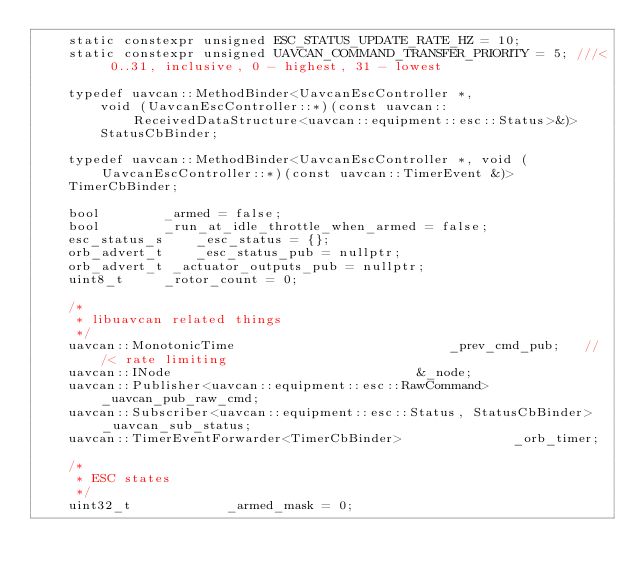Convert code to text. <code><loc_0><loc_0><loc_500><loc_500><_C++_>	static constexpr unsigned ESC_STATUS_UPDATE_RATE_HZ = 10;
	static constexpr unsigned UAVCAN_COMMAND_TRANSFER_PRIORITY = 5;	///< 0..31, inclusive, 0 - highest, 31 - lowest

	typedef uavcan::MethodBinder<UavcanEscController *,
		void (UavcanEscController::*)(const uavcan::ReceivedDataStructure<uavcan::equipment::esc::Status>&)>
		StatusCbBinder;

	typedef uavcan::MethodBinder<UavcanEscController *, void (UavcanEscController::*)(const uavcan::TimerEvent &)>
	TimerCbBinder;

	bool		_armed = false;
	bool		_run_at_idle_throttle_when_armed = false;
	esc_status_s	_esc_status = {};
	orb_advert_t	_esc_status_pub = nullptr;
	orb_advert_t _actuator_outputs_pub = nullptr;
	uint8_t		_rotor_count = 0;

	/*
	 * libuavcan related things
	 */
	uavcan::MonotonicTime							_prev_cmd_pub;   ///< rate limiting
	uavcan::INode								&_node;
	uavcan::Publisher<uavcan::equipment::esc::RawCommand>			_uavcan_pub_raw_cmd;
	uavcan::Subscriber<uavcan::equipment::esc::Status, StatusCbBinder>	_uavcan_sub_status;
	uavcan::TimerEventForwarder<TimerCbBinder>				_orb_timer;

	/*
	 * ESC states
	 */
	uint32_t 			_armed_mask = 0;</code> 